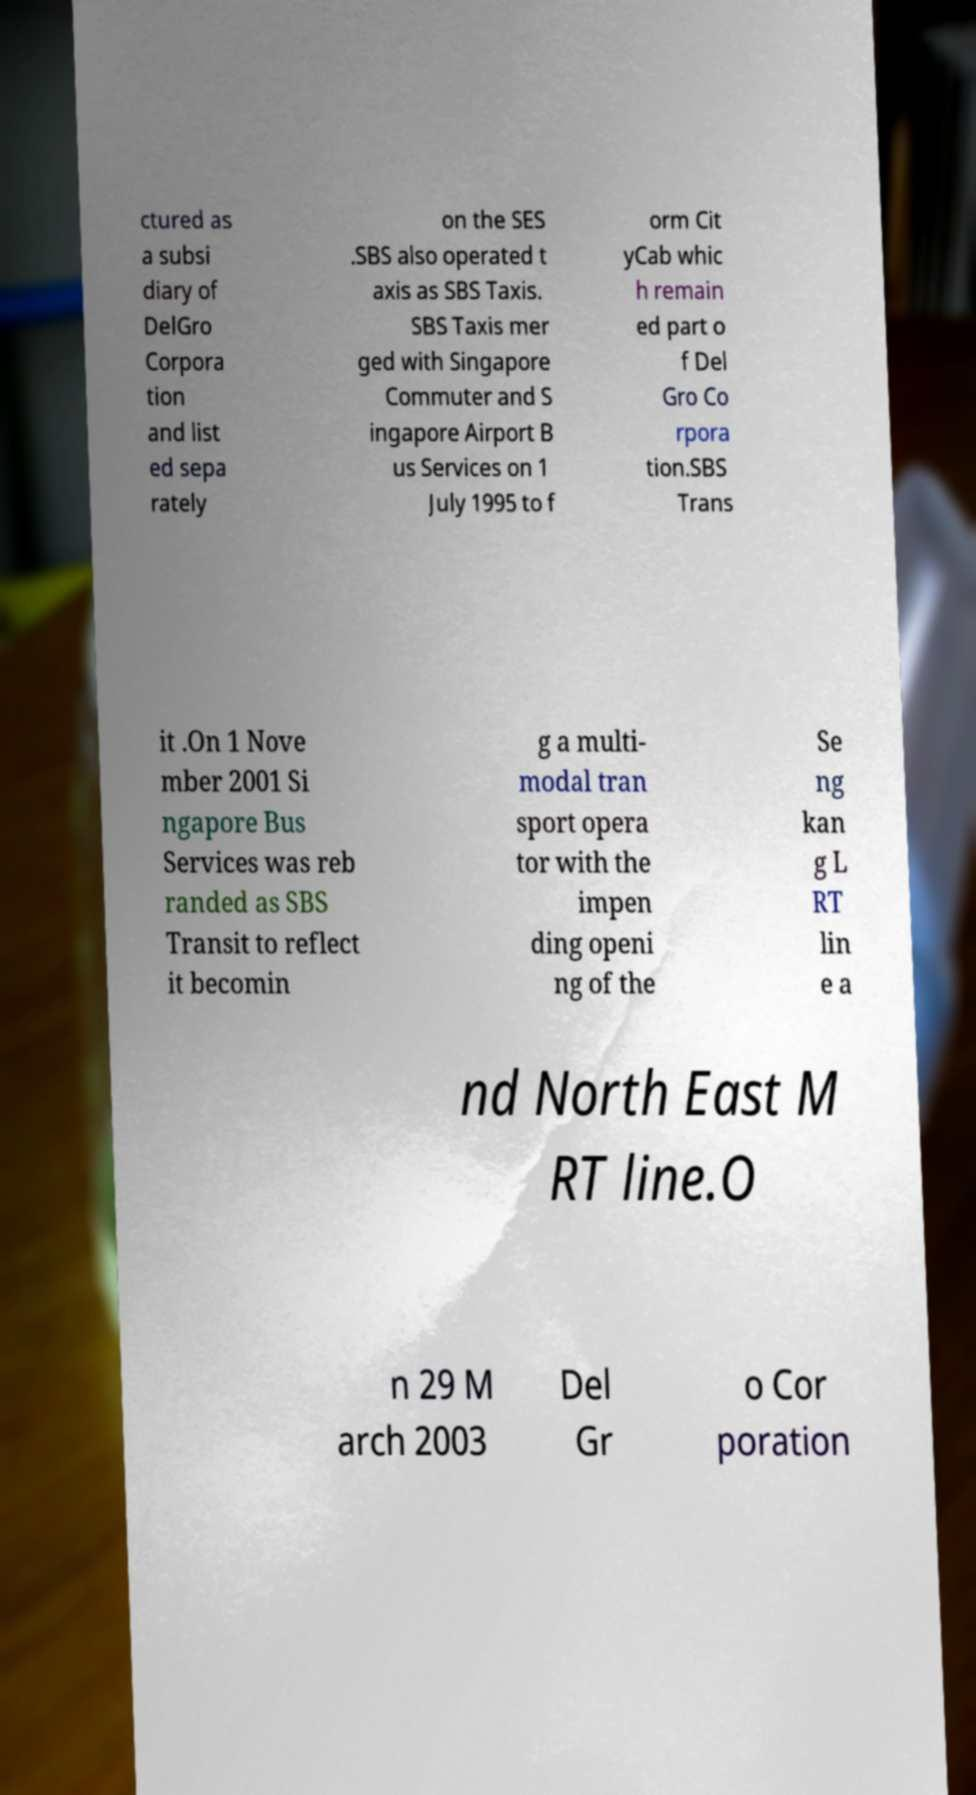What messages or text are displayed in this image? I need them in a readable, typed format. ctured as a subsi diary of DelGro Corpora tion and list ed sepa rately on the SES .SBS also operated t axis as SBS Taxis. SBS Taxis mer ged with Singapore Commuter and S ingapore Airport B us Services on 1 July 1995 to f orm Cit yCab whic h remain ed part o f Del Gro Co rpora tion.SBS Trans it .On 1 Nove mber 2001 Si ngapore Bus Services was reb randed as SBS Transit to reflect it becomin g a multi- modal tran sport opera tor with the impen ding openi ng of the Se ng kan g L RT lin e a nd North East M RT line.O n 29 M arch 2003 Del Gr o Cor poration 